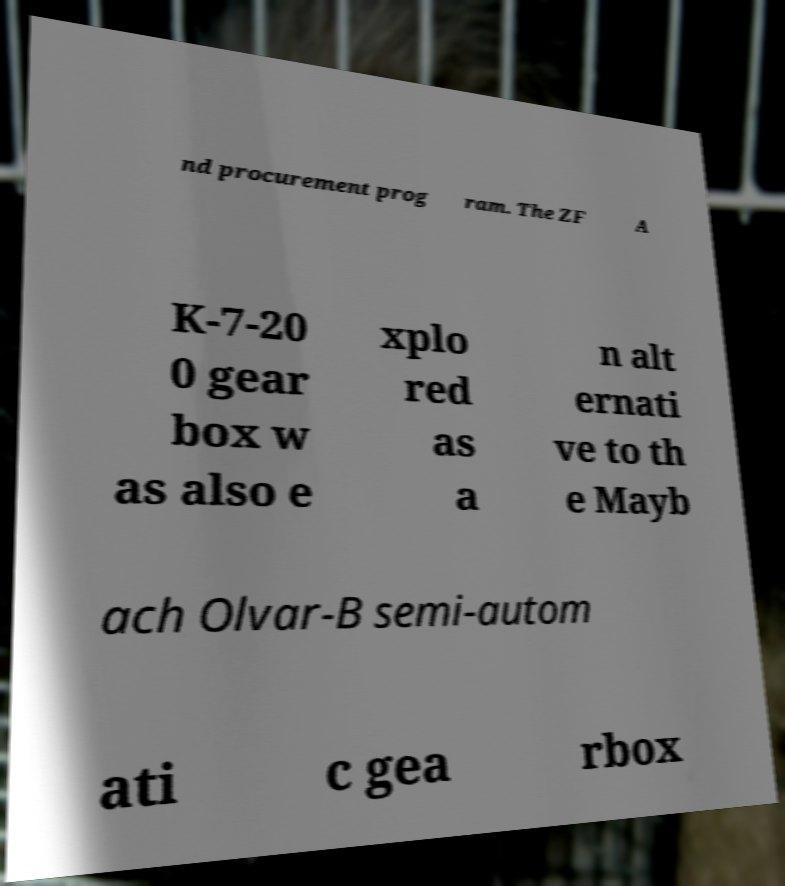Can you read and provide the text displayed in the image?This photo seems to have some interesting text. Can you extract and type it out for me? nd procurement prog ram. The ZF A K-7-20 0 gear box w as also e xplo red as a n alt ernati ve to th e Mayb ach Olvar-B semi-autom ati c gea rbox 